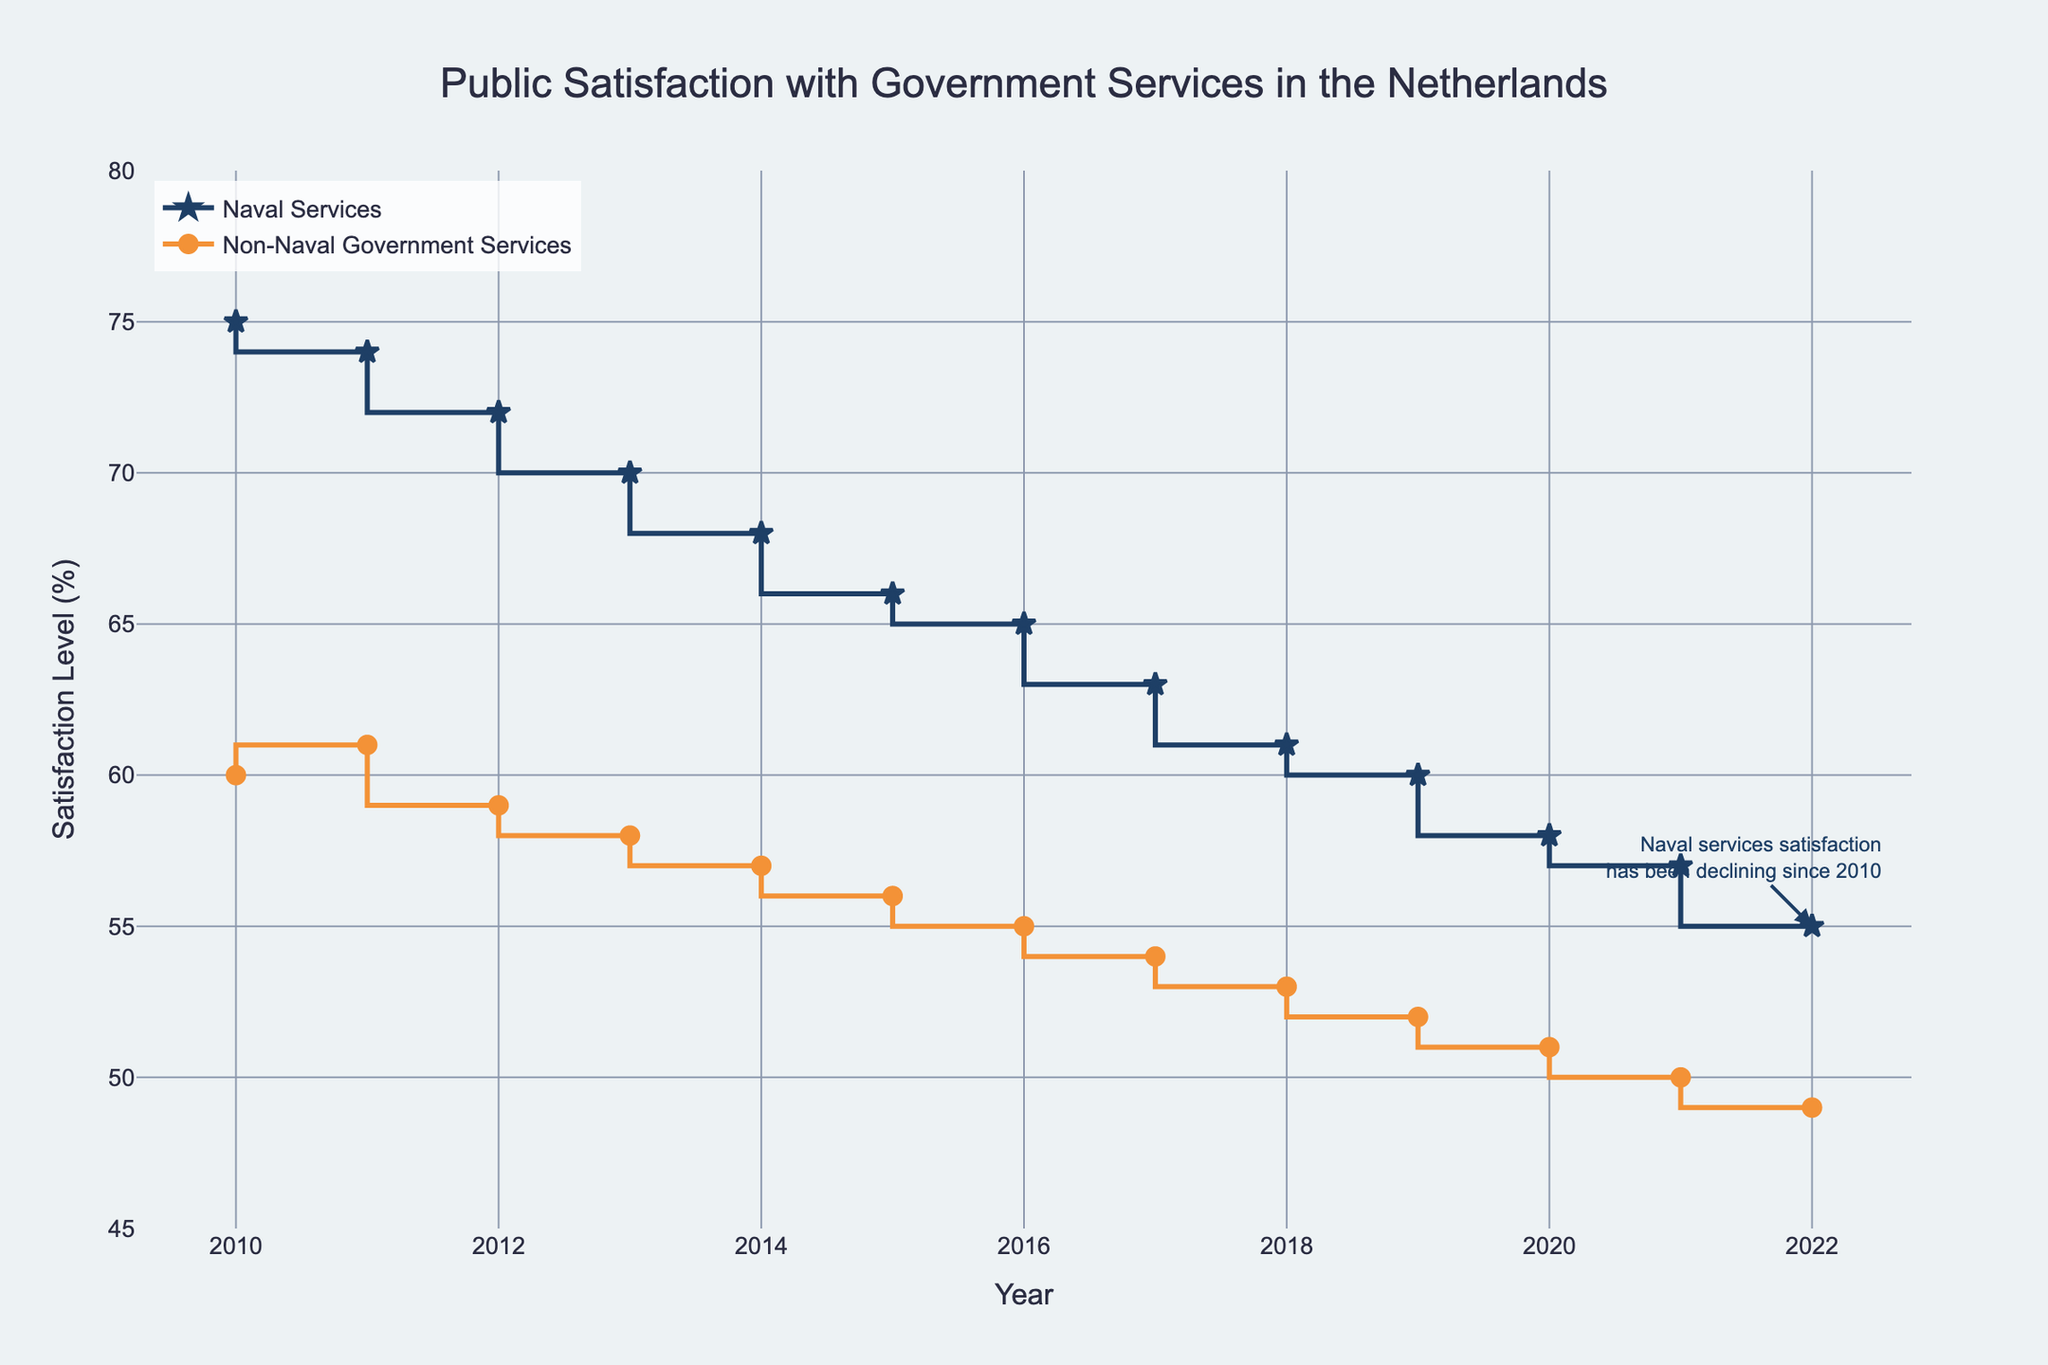How many years of data are represented in the figure? The x-axis shows the data is from 2010 to 2022, which is 13 years.
Answer: 13 What is the general trend for public satisfaction with naval services over the period? The line for naval services shows a consistent decline from 75% in 2010 to 55% in 2022.
Answer: Declining How does public satisfaction with non-naval government services in 2022 compare to that in 2010? In 2010, the satisfaction level was 60%, and in 2022 it was 49%. The satisfaction level decreased by 11%.
Answer: Decreased by 11% Which year had the smallest gap between satisfaction levels of naval and non-naval services? The smallest gap can be seen in 2011 where the delta is (74 - 61) = 13%.
Answer: 2011 What set of years saw the steepest drop in public satisfaction with naval services? Observing the figure, the steepest drop appears between 2013 (70%) and 2014 (68%), i.e., a 2% drop.
Answer: 2013 to 2014 In which year did public satisfaction with non-naval government services first drop below 55%? Public satisfaction with non-naval services dropped to 54% in 2017.
Answer: 2017 How much did the public satisfaction with naval services drop from 2010 to 2015? The satisfaction level decreased from 75% to 66%, a total drop of 9%.
Answer: 9% Which service (naval or non-naval) had a higher satisfaction level in 2020, and by how much? In 2020, naval services had 58%, non-naval services had 51%. The difference is 7%.
Answer: Naval services by 7% What does the annotation in the figure highlight? The annotation points out that the naval services satisfaction has been declining since 2010.
Answer: Decline since 2010 Compare the trends for both naval and non-naval services from 2010 to 2022. Both trends show a decline, but the satisfaction level for naval services starts higher and declines more sharply compared to non-naval services.
Answer: Both declined, naval services more sharply 